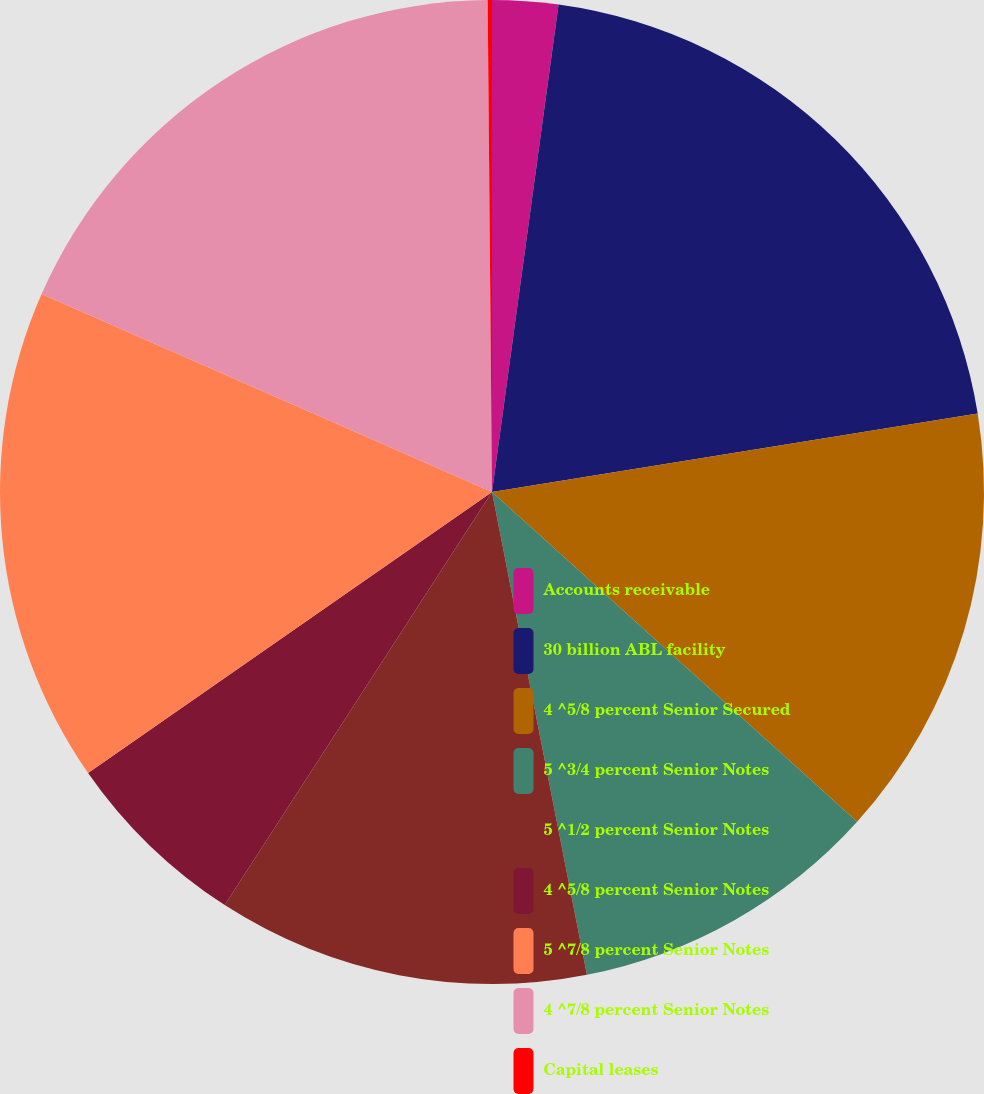<chart> <loc_0><loc_0><loc_500><loc_500><pie_chart><fcel>Accounts receivable<fcel>30 billion ABL facility<fcel>4 ^5/8 percent Senior Secured<fcel>5 ^3/4 percent Senior Notes<fcel>5 ^1/2 percent Senior Notes<fcel>4 ^5/8 percent Senior Notes<fcel>5 ^7/8 percent Senior Notes<fcel>4 ^7/8 percent Senior Notes<fcel>Capital leases<nl><fcel>2.16%<fcel>20.29%<fcel>14.24%<fcel>10.22%<fcel>12.23%<fcel>6.19%<fcel>16.26%<fcel>18.27%<fcel>0.14%<nl></chart> 